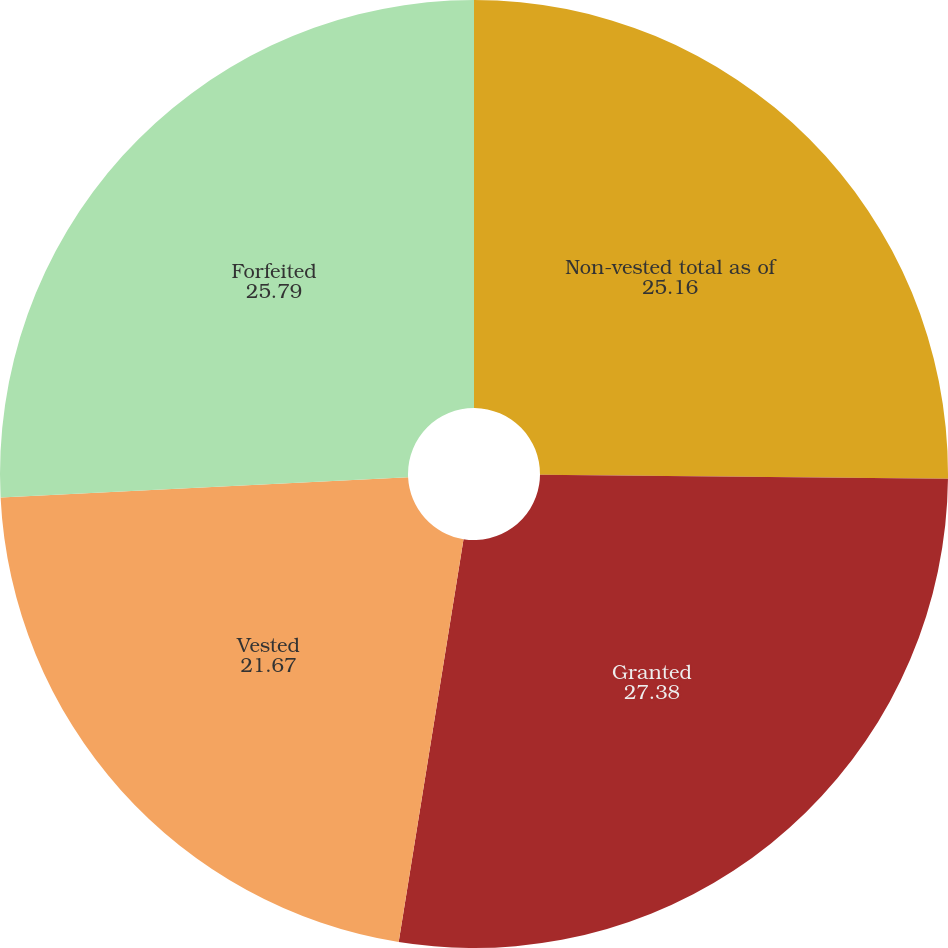<chart> <loc_0><loc_0><loc_500><loc_500><pie_chart><fcel>Non-vested total as of<fcel>Granted<fcel>Vested<fcel>Forfeited<nl><fcel>25.16%<fcel>27.38%<fcel>21.67%<fcel>25.79%<nl></chart> 